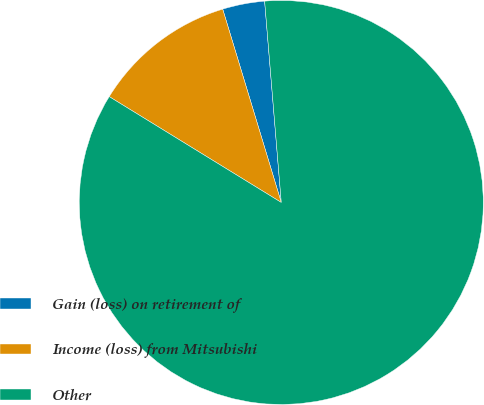Convert chart to OTSL. <chart><loc_0><loc_0><loc_500><loc_500><pie_chart><fcel>Gain (loss) on retirement of<fcel>Income (loss) from Mitsubishi<fcel>Other<nl><fcel>3.37%<fcel>11.54%<fcel>85.08%<nl></chart> 